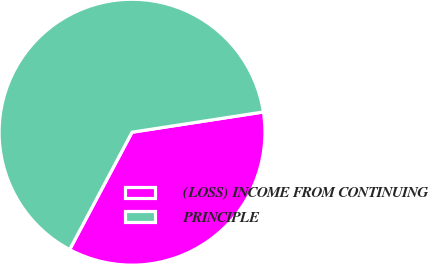Convert chart to OTSL. <chart><loc_0><loc_0><loc_500><loc_500><pie_chart><fcel>(LOSS) INCOME FROM CONTINUING<fcel>PRINCIPLE<nl><fcel>35.21%<fcel>64.79%<nl></chart> 